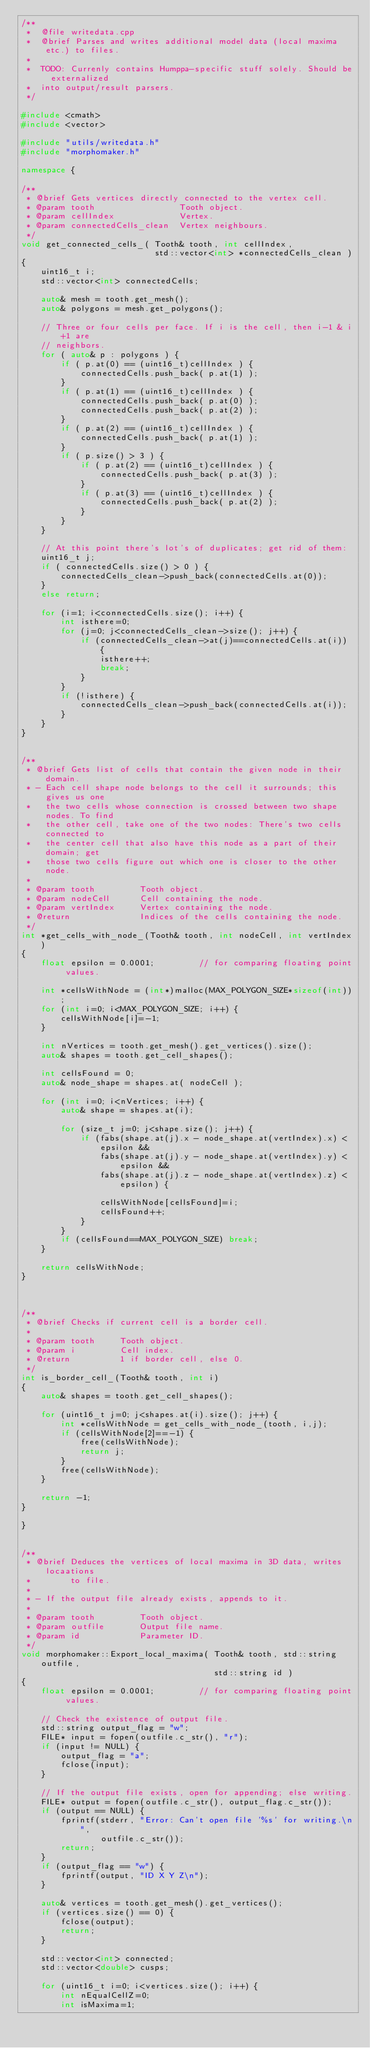<code> <loc_0><loc_0><loc_500><loc_500><_C++_>/**
 *  @file writedata.cpp
 *  @brief Parses and writes additional model data (local maxima etc.) to files.
 *
 *  TODO: Currenly contains Humppa-specific stuff solely. Should be externalized
 *  into output/result parsers.
 */

#include <cmath>
#include <vector>

#include "utils/writedata.h"
#include "morphomaker.h"

namespace {

/**
 * @brief Gets vertices directly connected to the vertex cell.
 * @param tooth                 Tooth object.
 * @param cellIndex             Vertex.
 * @param connectedCells_clean  Vertex neighbours.
 */
void get_connected_cells_( Tooth& tooth, int cellIndex,
                           std::vector<int> *connectedCells_clean )
{
    uint16_t i;
    std::vector<int> connectedCells;

    auto& mesh = tooth.get_mesh();
    auto& polygons = mesh.get_polygons();

    // Three or four cells per face. If i is the cell, then i-1 & i+1 are
    // neighbors.
    for ( auto& p : polygons ) {
        if ( p.at(0) == (uint16_t)cellIndex ) {
            connectedCells.push_back( p.at(1) );
        }
        if ( p.at(1) == (uint16_t)cellIndex ) {
            connectedCells.push_back( p.at(0) );
            connectedCells.push_back( p.at(2) );
        }
        if ( p.at(2) == (uint16_t)cellIndex ) {
            connectedCells.push_back( p.at(1) );
        }
        if ( p.size() > 3 ) {
            if ( p.at(2) == (uint16_t)cellIndex ) {
                connectedCells.push_back( p.at(3) );
            }
            if ( p.at(3) == (uint16_t)cellIndex ) {
                connectedCells.push_back( p.at(2) );
            }
        }
    }

    // At this point there's lot's of duplicates; get rid of them:
    uint16_t j;
    if ( connectedCells.size() > 0 ) {
        connectedCells_clean->push_back(connectedCells.at(0));
    }
    else return;

    for (i=1; i<connectedCells.size(); i++) {
        int isthere=0;
        for (j=0; j<connectedCells_clean->size(); j++) {
            if (connectedCells_clean->at(j)==connectedCells.at(i)) {
                isthere++;
                break;
            }
        }
        if (!isthere) {
            connectedCells_clean->push_back(connectedCells.at(i));
        }
    }
}


/**
 * @brief Gets list of cells that contain the given node in their domain.
 * - Each cell shape node belongs to the cell it surrounds; this gives us one
 *   the two cells whose connection is crossed between two shape nodes. To find
 *   the other cell, take one of the two nodes: There's two cells connected to
 *   the center cell that also have this node as a part of their domain; get
 *   those two cells figure out which one is closer to the other node.
 *
 * @param tooth         Tooth object.
 * @param nodeCell      Cell containing the node.
 * @param vertIndex     Vertex containing the node.
 * @return              Indices of the cells containing the node.
 */
int *get_cells_with_node_(Tooth& tooth, int nodeCell, int vertIndex)
{
    float epsilon = 0.0001;         // for comparing floating point values.

    int *cellsWithNode = (int*)malloc(MAX_POLYGON_SIZE*sizeof(int));
    for (int i=0; i<MAX_POLYGON_SIZE; i++) {
        cellsWithNode[i]=-1;
    }

    int nVertices = tooth.get_mesh().get_vertices().size();
    auto& shapes = tooth.get_cell_shapes();

    int cellsFound = 0;
    auto& node_shape = shapes.at( nodeCell );

    for (int i=0; i<nVertices; i++) {
        auto& shape = shapes.at(i);

        for (size_t j=0; j<shape.size(); j++) {
            if (fabs(shape.at(j).x - node_shape.at(vertIndex).x) < epsilon &&
                fabs(shape.at(j).y - node_shape.at(vertIndex).y) < epsilon &&
                fabs(shape.at(j).z - node_shape.at(vertIndex).z) < epsilon) {

                cellsWithNode[cellsFound]=i;
                cellsFound++;
            }
        }
        if (cellsFound==MAX_POLYGON_SIZE) break;
    }

    return cellsWithNode;
}



/**
 * @brief Checks if current cell is a border cell.
 *
 * @param tooth     Tooth object.
 * @param i         Cell index.
 * @return          1 if border cell, else 0.
 */
int is_border_cell_(Tooth& tooth, int i)
{
    auto& shapes = tooth.get_cell_shapes();

    for (uint16_t j=0; j<shapes.at(i).size(); j++) {
        int *cellsWithNode = get_cells_with_node_(tooth, i,j);
        if (cellsWithNode[2]==-1) {
            free(cellsWithNode);
            return j;
        }
        free(cellsWithNode);
    }

    return -1;
}

}


/**
 * @brief Deduces the vertices of local maxima in 3D data, writes locaations
 *        to file.
 *
 * - If the output file already exists, appends to it.
 *
 * @param tooth         Tooth object.
 * @param outfile       Output file name.
 * @param id            Parameter ID.
 */
void morphomaker::Export_local_maxima( Tooth& tooth, std::string outfile,
                                       std::string id )
{
    float epsilon = 0.0001;         // for comparing floating point values.

    // Check the existence of output file.
    std::string output_flag = "w";
    FILE* input = fopen(outfile.c_str(), "r");
    if (input != NULL) {
        output_flag = "a";
        fclose(input);
    }

    // If the output file exists, open for appending; else writing.
    FILE* output = fopen(outfile.c_str(), output_flag.c_str());
    if (output == NULL) {
        fprintf(stderr, "Error: Can't open file '%s' for writing.\n",
                outfile.c_str());
        return;
    }
    if (output_flag == "w") {
        fprintf(output, "ID X Y Z\n");
    }

    auto& vertices = tooth.get_mesh().get_vertices();
    if (vertices.size() == 0) {
        fclose(output);
        return;
    }

    std::vector<int> connected;
    std::vector<double> cusps;

    for (uint16_t i=0; i<vertices.size(); i++) {
        int nEqualCellZ=0;
        int isMaxima=1;</code> 